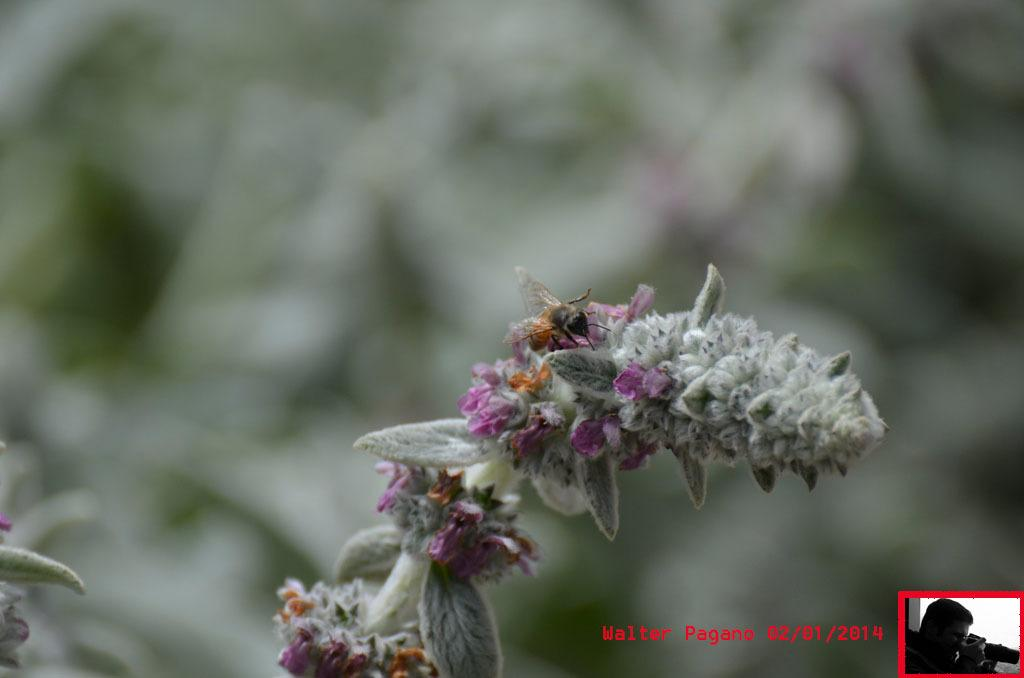What type of insect is present in the image? There is a honey bee in the image. What is the honey bee doing in the image? The honey bee is sitting on a flower or plant in the image. Can you describe the background of the image? The background of the image is blurred. How many apples are hanging from the honey bee in the image? There are no apples present in the image, and the honey bee is not holding or attached to any apples. 